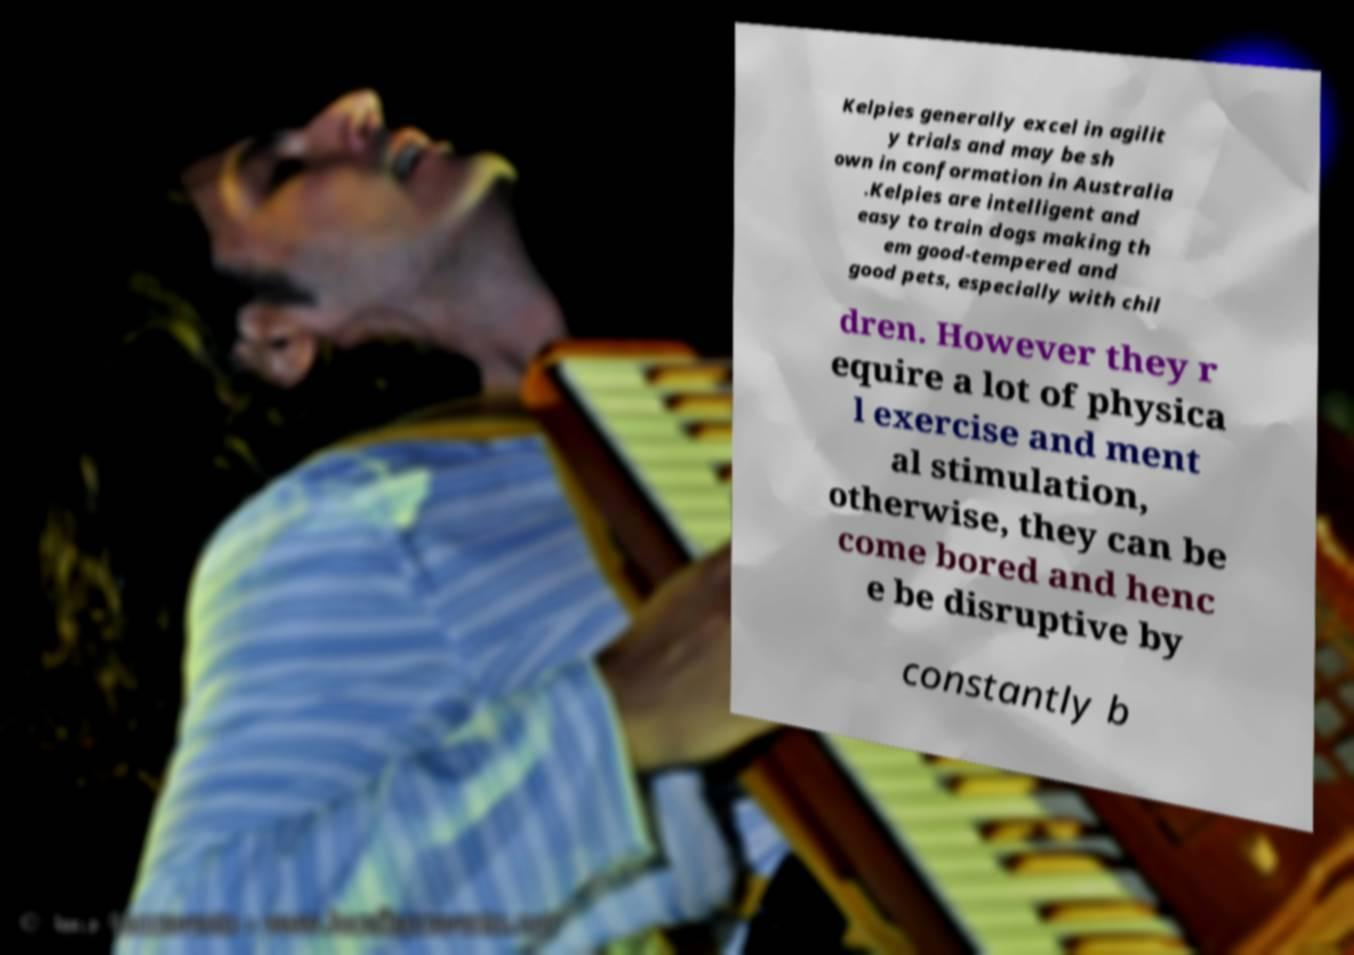Can you accurately transcribe the text from the provided image for me? Kelpies generally excel in agilit y trials and may be sh own in conformation in Australia .Kelpies are intelligent and easy to train dogs making th em good-tempered and good pets, especially with chil dren. However they r equire a lot of physica l exercise and ment al stimulation, otherwise, they can be come bored and henc e be disruptive by constantly b 